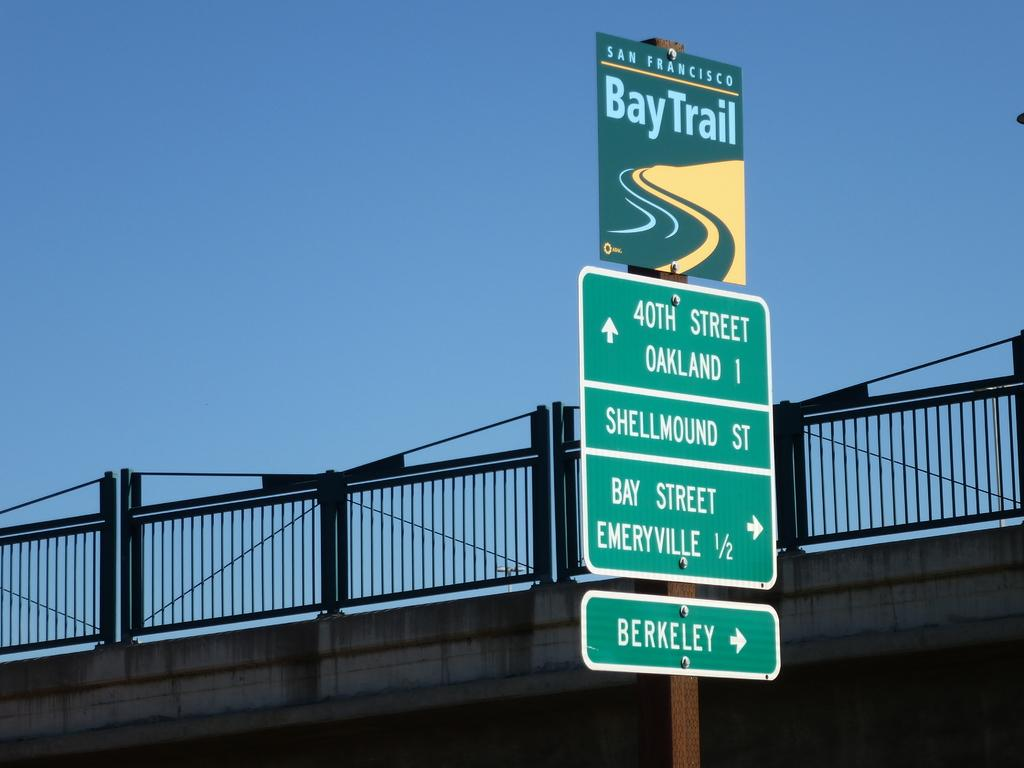<image>
Write a terse but informative summary of the picture. The Bay Trail sign in San Francisco says Bay Street and Berkeley are to the right and 40th Street is ahead. 